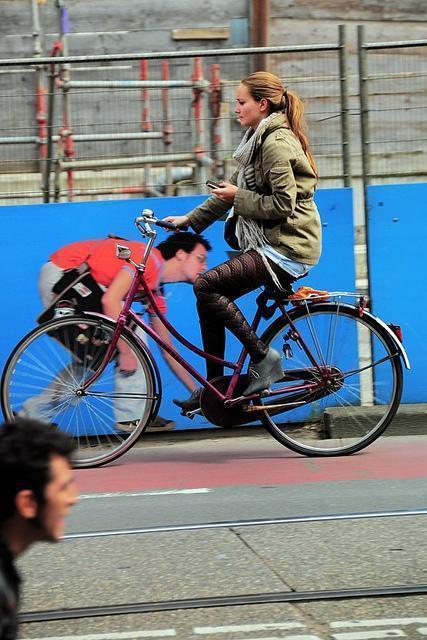What does the object use to speed?
Indicate the correct response and explain using: 'Answer: answer
Rationale: rationale.'
Options: Gas, gears, engine, fire. Answer: gears.
Rationale: It is a bicycle, which are known to basically all have gears to shift speeds. bicycles are manually powered (meaning, without the use of a combustible). 